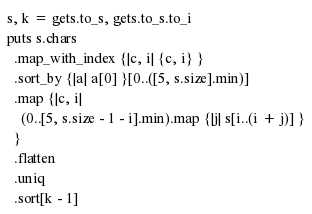Convert code to text. <code><loc_0><loc_0><loc_500><loc_500><_Crystal_>s, k = gets.to_s, gets.to_s.to_i
puts s.chars
  .map_with_index {|c, i| {c, i} }
  .sort_by {|a| a[0] }[0..([5, s.size].min)]
  .map {|c, i|
    (0..[5, s.size - 1 - i].min).map {|j| s[i..(i + j)] }
  }
  .flatten
  .uniq
  .sort[k - 1]</code> 